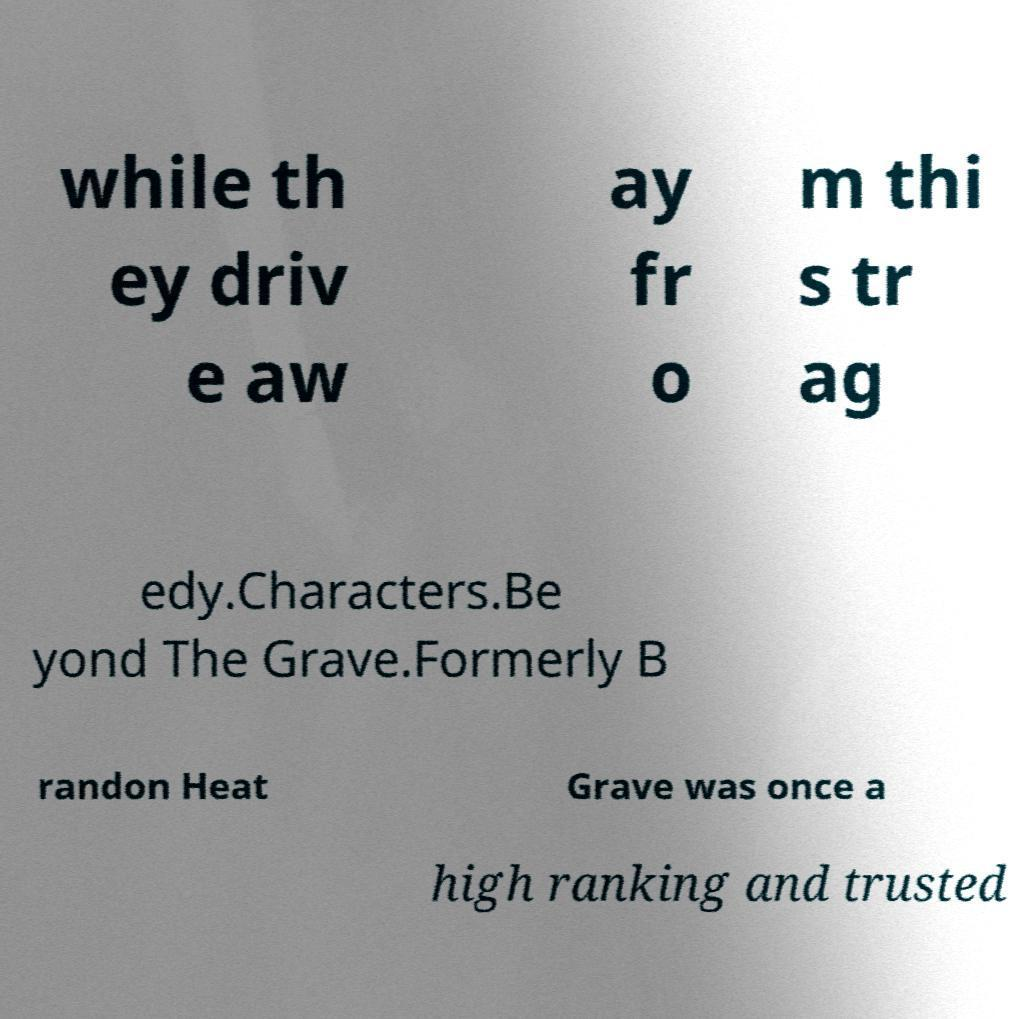Can you read and provide the text displayed in the image?This photo seems to have some interesting text. Can you extract and type it out for me? while th ey driv e aw ay fr o m thi s tr ag edy.Characters.Be yond The Grave.Formerly B randon Heat Grave was once a high ranking and trusted 